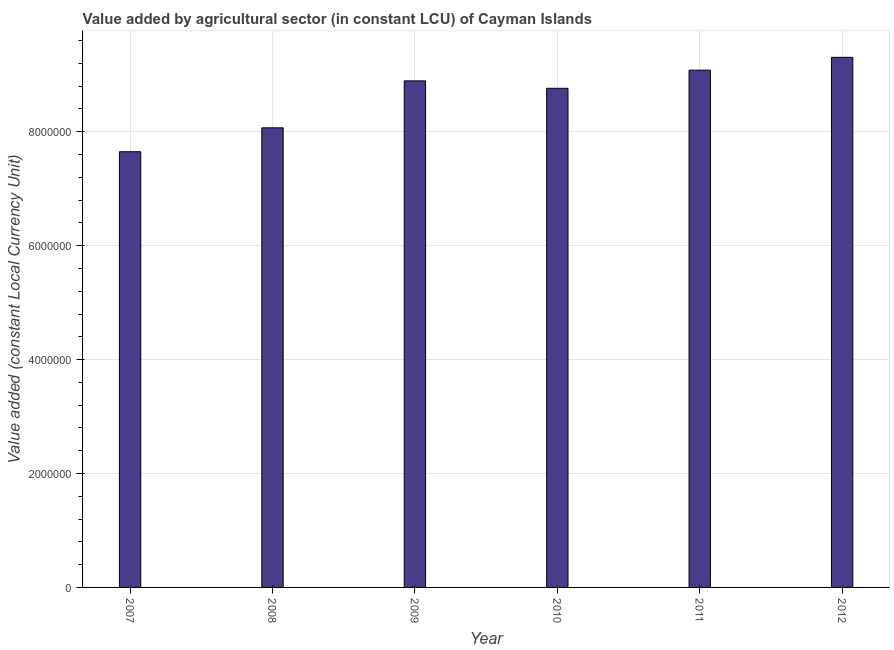What is the title of the graph?
Ensure brevity in your answer.  Value added by agricultural sector (in constant LCU) of Cayman Islands. What is the label or title of the Y-axis?
Give a very brief answer. Value added (constant Local Currency Unit). What is the value added by agriculture sector in 2007?
Keep it short and to the point. 7.65e+06. Across all years, what is the maximum value added by agriculture sector?
Provide a succinct answer. 9.31e+06. Across all years, what is the minimum value added by agriculture sector?
Offer a terse response. 7.65e+06. In which year was the value added by agriculture sector maximum?
Offer a very short reply. 2012. In which year was the value added by agriculture sector minimum?
Provide a short and direct response. 2007. What is the sum of the value added by agriculture sector?
Provide a succinct answer. 5.18e+07. What is the difference between the value added by agriculture sector in 2009 and 2011?
Make the answer very short. -1.88e+05. What is the average value added by agriculture sector per year?
Offer a terse response. 8.63e+06. What is the median value added by agriculture sector?
Your answer should be compact. 8.83e+06. What is the ratio of the value added by agriculture sector in 2008 to that in 2012?
Your answer should be compact. 0.87. What is the difference between the highest and the second highest value added by agriculture sector?
Keep it short and to the point. 2.25e+05. Is the sum of the value added by agriculture sector in 2009 and 2012 greater than the maximum value added by agriculture sector across all years?
Your response must be concise. Yes. What is the difference between the highest and the lowest value added by agriculture sector?
Provide a succinct answer. 1.66e+06. In how many years, is the value added by agriculture sector greater than the average value added by agriculture sector taken over all years?
Provide a succinct answer. 4. How many bars are there?
Your response must be concise. 6. How many years are there in the graph?
Provide a short and direct response. 6. What is the difference between two consecutive major ticks on the Y-axis?
Provide a succinct answer. 2.00e+06. Are the values on the major ticks of Y-axis written in scientific E-notation?
Offer a terse response. No. What is the Value added (constant Local Currency Unit) in 2007?
Give a very brief answer. 7.65e+06. What is the Value added (constant Local Currency Unit) of 2008?
Ensure brevity in your answer.  8.07e+06. What is the Value added (constant Local Currency Unit) of 2009?
Give a very brief answer. 8.89e+06. What is the Value added (constant Local Currency Unit) in 2010?
Ensure brevity in your answer.  8.76e+06. What is the Value added (constant Local Currency Unit) of 2011?
Your response must be concise. 9.08e+06. What is the Value added (constant Local Currency Unit) in 2012?
Your answer should be compact. 9.31e+06. What is the difference between the Value added (constant Local Currency Unit) in 2007 and 2008?
Offer a terse response. -4.19e+05. What is the difference between the Value added (constant Local Currency Unit) in 2007 and 2009?
Offer a very short reply. -1.24e+06. What is the difference between the Value added (constant Local Currency Unit) in 2007 and 2010?
Your answer should be compact. -1.11e+06. What is the difference between the Value added (constant Local Currency Unit) in 2007 and 2011?
Provide a short and direct response. -1.43e+06. What is the difference between the Value added (constant Local Currency Unit) in 2007 and 2012?
Your response must be concise. -1.66e+06. What is the difference between the Value added (constant Local Currency Unit) in 2008 and 2009?
Your answer should be compact. -8.25e+05. What is the difference between the Value added (constant Local Currency Unit) in 2008 and 2010?
Provide a short and direct response. -6.94e+05. What is the difference between the Value added (constant Local Currency Unit) in 2008 and 2011?
Your answer should be compact. -1.01e+06. What is the difference between the Value added (constant Local Currency Unit) in 2008 and 2012?
Your response must be concise. -1.24e+06. What is the difference between the Value added (constant Local Currency Unit) in 2009 and 2010?
Your answer should be very brief. 1.30e+05. What is the difference between the Value added (constant Local Currency Unit) in 2009 and 2011?
Your response must be concise. -1.88e+05. What is the difference between the Value added (constant Local Currency Unit) in 2009 and 2012?
Your response must be concise. -4.13e+05. What is the difference between the Value added (constant Local Currency Unit) in 2010 and 2011?
Offer a very short reply. -3.18e+05. What is the difference between the Value added (constant Local Currency Unit) in 2010 and 2012?
Your answer should be very brief. -5.44e+05. What is the difference between the Value added (constant Local Currency Unit) in 2011 and 2012?
Give a very brief answer. -2.25e+05. What is the ratio of the Value added (constant Local Currency Unit) in 2007 to that in 2008?
Provide a succinct answer. 0.95. What is the ratio of the Value added (constant Local Currency Unit) in 2007 to that in 2009?
Your answer should be very brief. 0.86. What is the ratio of the Value added (constant Local Currency Unit) in 2007 to that in 2010?
Offer a terse response. 0.87. What is the ratio of the Value added (constant Local Currency Unit) in 2007 to that in 2011?
Keep it short and to the point. 0.84. What is the ratio of the Value added (constant Local Currency Unit) in 2007 to that in 2012?
Offer a very short reply. 0.82. What is the ratio of the Value added (constant Local Currency Unit) in 2008 to that in 2009?
Your answer should be very brief. 0.91. What is the ratio of the Value added (constant Local Currency Unit) in 2008 to that in 2010?
Your answer should be compact. 0.92. What is the ratio of the Value added (constant Local Currency Unit) in 2008 to that in 2011?
Your response must be concise. 0.89. What is the ratio of the Value added (constant Local Currency Unit) in 2008 to that in 2012?
Keep it short and to the point. 0.87. What is the ratio of the Value added (constant Local Currency Unit) in 2009 to that in 2010?
Keep it short and to the point. 1.01. What is the ratio of the Value added (constant Local Currency Unit) in 2009 to that in 2012?
Offer a very short reply. 0.96. What is the ratio of the Value added (constant Local Currency Unit) in 2010 to that in 2012?
Your answer should be compact. 0.94. 